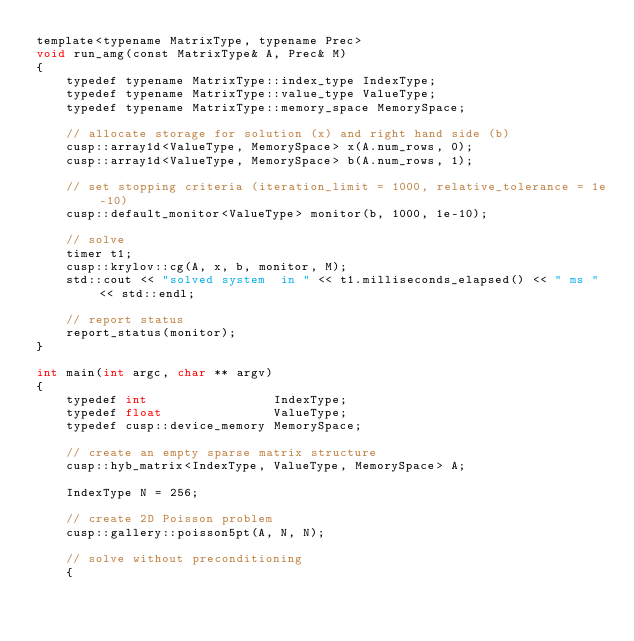Convert code to text. <code><loc_0><loc_0><loc_500><loc_500><_Cuda_>template<typename MatrixType, typename Prec>
void run_amg(const MatrixType& A, Prec& M)
{
    typedef typename MatrixType::index_type IndexType;
    typedef typename MatrixType::value_type ValueType;
    typedef typename MatrixType::memory_space MemorySpace;

    // allocate storage for solution (x) and right hand side (b)
    cusp::array1d<ValueType, MemorySpace> x(A.num_rows, 0);
    cusp::array1d<ValueType, MemorySpace> b(A.num_rows, 1);

    // set stopping criteria (iteration_limit = 1000, relative_tolerance = 1e-10)
    cusp::default_monitor<ValueType> monitor(b, 1000, 1e-10);

    // solve
    timer t1;
    cusp::krylov::cg(A, x, b, monitor, M);
    std::cout << "solved system  in " << t1.milliseconds_elapsed() << " ms " << std::endl;

    // report status
    report_status(monitor);
}

int main(int argc, char ** argv)
{
    typedef int                 IndexType;
    typedef float               ValueType;
    typedef cusp::device_memory MemorySpace;

    // create an empty sparse matrix structure
    cusp::hyb_matrix<IndexType, ValueType, MemorySpace> A;

    IndexType N = 256;

    // create 2D Poisson problem
    cusp::gallery::poisson5pt(A, N, N);

    // solve without preconditioning
    {</code> 